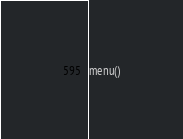<code> <loc_0><loc_0><loc_500><loc_500><_Python_>
menu()
</code> 